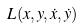Convert formula to latex. <formula><loc_0><loc_0><loc_500><loc_500>L ( x , y , \dot { x } , \dot { y } )</formula> 